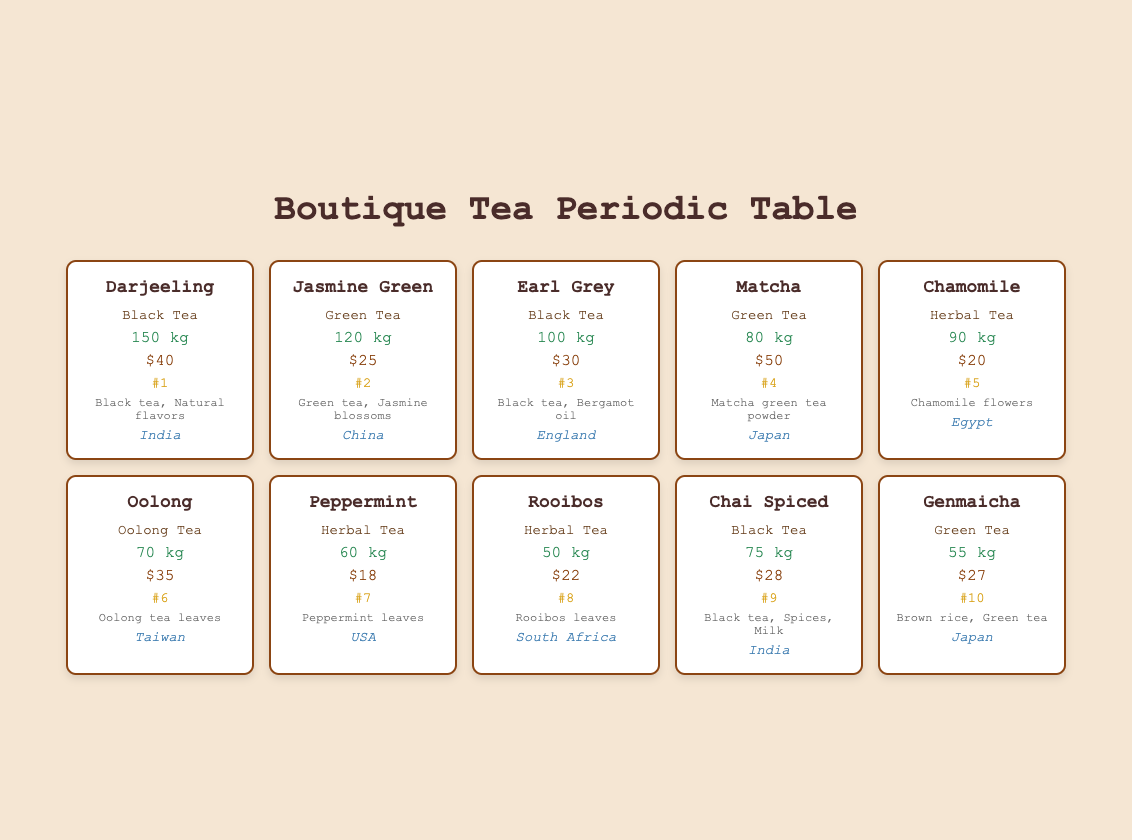What's the sales volume of Chamomile tea? The sales volume of Chamomile tea is directly provided in the table. It states that Chamomile tea has a sales volume of 90 kg.
Answer: 90 kg Which variety has the highest average price? To find the highest average price, we need to look at the "Average Price" column and compare the values. The Matcha tea has the highest average price at $50.
Answer: Matcha Is the popularity rank of Oolong tea greater than 5? The popularity rank of Oolong tea is listed as #6. Since 6 is greater than 5, the statement is true.
Answer: Yes What is the total sales volume of all the herbal teas combined? We identify the herbal teas (Chamomile, Peppermint, and Rooibos) and add their sales volumes: 90 kg (Chamomile) + 60 kg (Peppermint) + 50 kg (Rooibos) = 200 kg.
Answer: 200 kg Which variety of tea from India has the highest sales volume? The two varieties of tea from India are Darjeeling (150 kg) and Chai Spiced (75 kg). Since 150 kg is greater than 75 kg, Darjeeling has the highest sales volume.
Answer: Darjeeling What is the average price of the green tea varieties? The green tea varieties are Jasmine Green ($25), Matcha ($50), and Genmaicha ($27). We sum them up: $25 + $50 + $27 = $102 and divide by the total of 3 varieties, which gives us an average price of $102 / 3 = $34.
Answer: $34 Is Rooibos tea more popular than Chamomile tea? Rooibos tea has a popularity rank of #8, while Chamomile tea has a rank of #5. Since 8 is greater than 5, Rooibos is less popular than Chamomile.
Answer: No How many kilograms of Black Tea were sold in total? The black tea varieties are Darjeeling (150 kg), Earl Grey (100 kg), and Chai Spiced (75 kg). We add their sales: 150 kg + 100 kg + 75 kg = 325 kg.
Answer: 325 kg What percentage of total sales volume does the Oolong tea represent? The total sales volume is 150 kg (Darjeeling) + 120 kg (Jasmine Green) + 100 kg (Earl Grey) + 80 kg (Matcha) + 90 kg (Chamomile) + 70 kg (Oolong) + 60 kg (Peppermint) + 50 kg (Rooibos) + 75 kg (Chai Spiced) + 55 kg (Genmaicha) = 1,000 kg. Oolong sales volume is 70 kg. Thus, the percentage is calculated as (70 kg / 1000 kg) * 100% = 7%.
Answer: 7% 